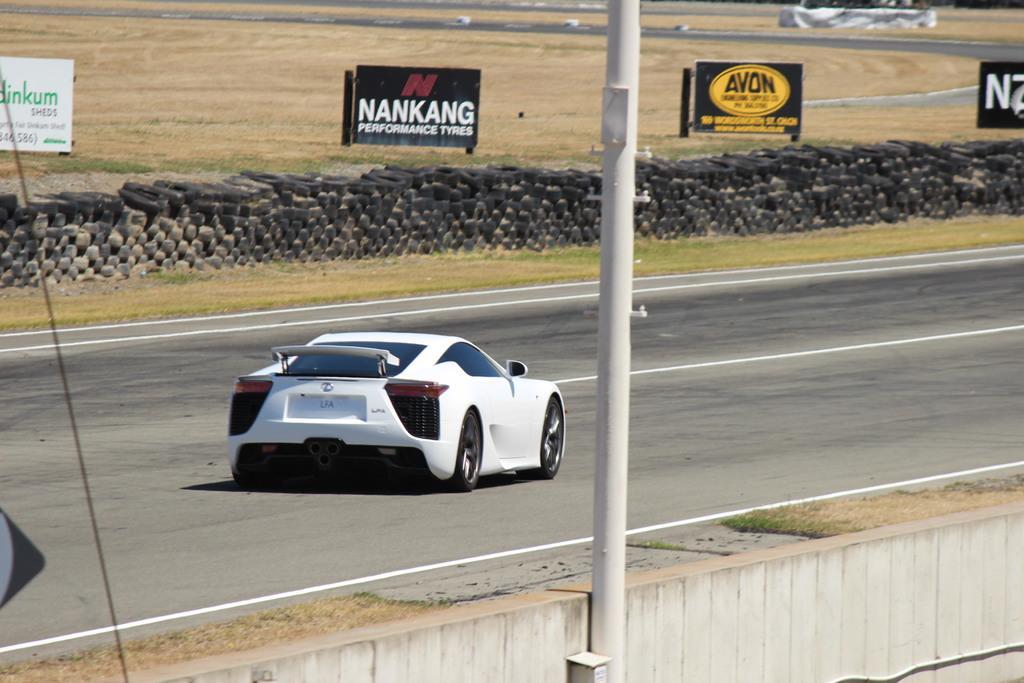Can you describe this image briefly? In this image, we can see a car on the road. There some tires and board beside the road. There is a pole in the middle of the image. 